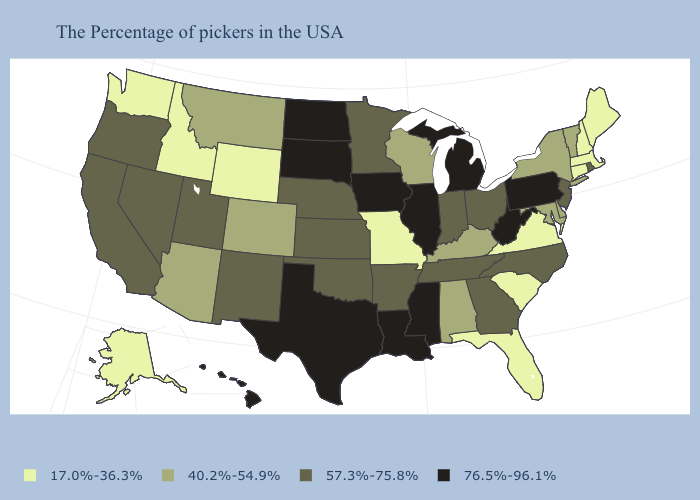Does South Dakota have the highest value in the USA?
Keep it brief. Yes. Name the states that have a value in the range 76.5%-96.1%?
Write a very short answer. Pennsylvania, West Virginia, Michigan, Illinois, Mississippi, Louisiana, Iowa, Texas, South Dakota, North Dakota, Hawaii. Name the states that have a value in the range 40.2%-54.9%?
Give a very brief answer. Vermont, New York, Delaware, Maryland, Kentucky, Alabama, Wisconsin, Colorado, Montana, Arizona. Does Wisconsin have the same value as Nebraska?
Concise answer only. No. What is the value of Montana?
Short answer required. 40.2%-54.9%. What is the value of Alaska?
Keep it brief. 17.0%-36.3%. Name the states that have a value in the range 17.0%-36.3%?
Write a very short answer. Maine, Massachusetts, New Hampshire, Connecticut, Virginia, South Carolina, Florida, Missouri, Wyoming, Idaho, Washington, Alaska. What is the lowest value in states that border Kentucky?
Write a very short answer. 17.0%-36.3%. What is the value of Illinois?
Keep it brief. 76.5%-96.1%. Among the states that border Colorado , which have the highest value?
Be succinct. Kansas, Nebraska, Oklahoma, New Mexico, Utah. Name the states that have a value in the range 57.3%-75.8%?
Short answer required. Rhode Island, New Jersey, North Carolina, Ohio, Georgia, Indiana, Tennessee, Arkansas, Minnesota, Kansas, Nebraska, Oklahoma, New Mexico, Utah, Nevada, California, Oregon. Which states hav the highest value in the MidWest?
Keep it brief. Michigan, Illinois, Iowa, South Dakota, North Dakota. Does New Hampshire have the same value as Massachusetts?
Be succinct. Yes. Does Hawaii have a higher value than New Hampshire?
Give a very brief answer. Yes. 